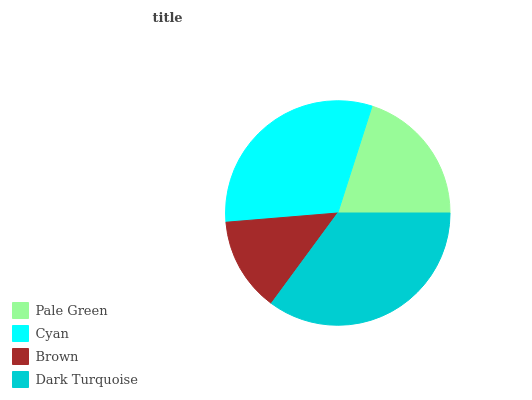Is Brown the minimum?
Answer yes or no. Yes. Is Dark Turquoise the maximum?
Answer yes or no. Yes. Is Cyan the minimum?
Answer yes or no. No. Is Cyan the maximum?
Answer yes or no. No. Is Cyan greater than Pale Green?
Answer yes or no. Yes. Is Pale Green less than Cyan?
Answer yes or no. Yes. Is Pale Green greater than Cyan?
Answer yes or no. No. Is Cyan less than Pale Green?
Answer yes or no. No. Is Cyan the high median?
Answer yes or no. Yes. Is Pale Green the low median?
Answer yes or no. Yes. Is Brown the high median?
Answer yes or no. No. Is Brown the low median?
Answer yes or no. No. 